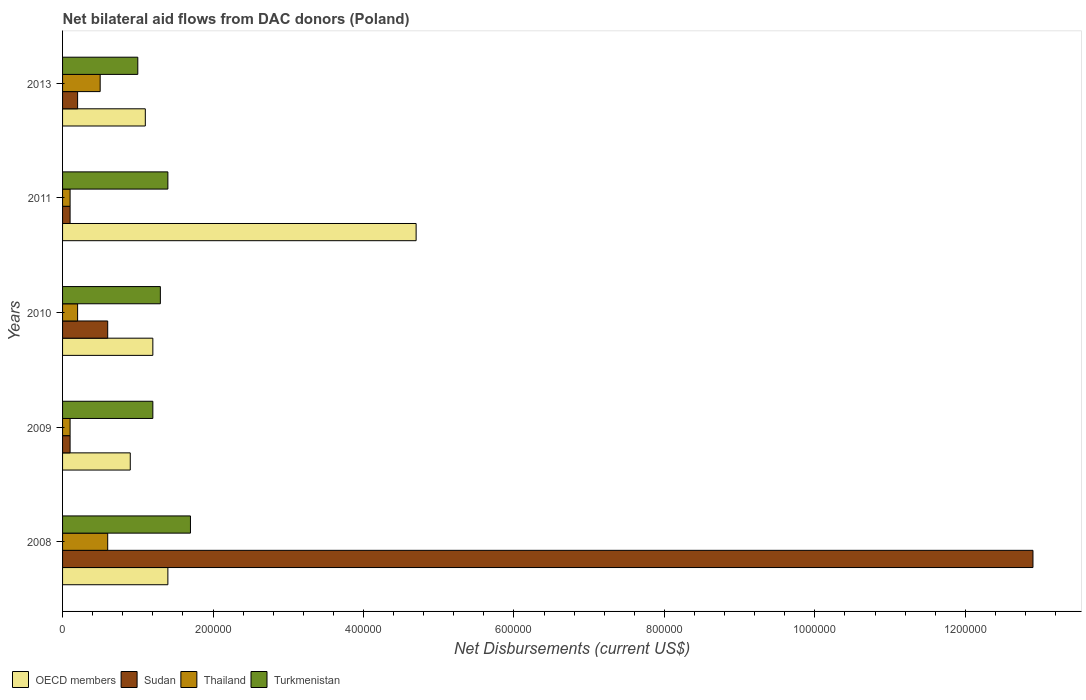How many different coloured bars are there?
Ensure brevity in your answer.  4. Are the number of bars on each tick of the Y-axis equal?
Provide a short and direct response. Yes. How many bars are there on the 4th tick from the bottom?
Provide a succinct answer. 4. In how many cases, is the number of bars for a given year not equal to the number of legend labels?
Provide a short and direct response. 0. Across all years, what is the maximum net bilateral aid flows in Sudan?
Keep it short and to the point. 1.29e+06. Across all years, what is the minimum net bilateral aid flows in Turkmenistan?
Provide a succinct answer. 1.00e+05. What is the total net bilateral aid flows in Sudan in the graph?
Your answer should be compact. 1.39e+06. What is the difference between the net bilateral aid flows in Thailand in 2010 and that in 2013?
Offer a terse response. -3.00e+04. What is the difference between the net bilateral aid flows in Sudan in 2009 and the net bilateral aid flows in OECD members in 2013?
Provide a succinct answer. -1.00e+05. What is the average net bilateral aid flows in Sudan per year?
Offer a terse response. 2.78e+05. In the year 2011, what is the difference between the net bilateral aid flows in OECD members and net bilateral aid flows in Sudan?
Your answer should be very brief. 4.60e+05. What is the ratio of the net bilateral aid flows in Turkmenistan in 2009 to that in 2013?
Offer a very short reply. 1.2. Is the net bilateral aid flows in Turkmenistan in 2009 less than that in 2011?
Keep it short and to the point. Yes. Is the difference between the net bilateral aid flows in OECD members in 2010 and 2013 greater than the difference between the net bilateral aid flows in Sudan in 2010 and 2013?
Your answer should be very brief. No. What is the difference between the highest and the second highest net bilateral aid flows in Turkmenistan?
Provide a succinct answer. 3.00e+04. What is the difference between the highest and the lowest net bilateral aid flows in OECD members?
Provide a short and direct response. 3.80e+05. In how many years, is the net bilateral aid flows in Turkmenistan greater than the average net bilateral aid flows in Turkmenistan taken over all years?
Your response must be concise. 2. Is the sum of the net bilateral aid flows in Sudan in 2010 and 2013 greater than the maximum net bilateral aid flows in Turkmenistan across all years?
Your answer should be very brief. No. Is it the case that in every year, the sum of the net bilateral aid flows in Sudan and net bilateral aid flows in OECD members is greater than the sum of net bilateral aid flows in Turkmenistan and net bilateral aid flows in Thailand?
Make the answer very short. Yes. What does the 1st bar from the top in 2009 represents?
Provide a short and direct response. Turkmenistan. What does the 4th bar from the bottom in 2010 represents?
Your answer should be compact. Turkmenistan. Is it the case that in every year, the sum of the net bilateral aid flows in Turkmenistan and net bilateral aid flows in Sudan is greater than the net bilateral aid flows in OECD members?
Your response must be concise. No. Are all the bars in the graph horizontal?
Provide a short and direct response. Yes. Does the graph contain grids?
Provide a short and direct response. No. How many legend labels are there?
Your answer should be compact. 4. How are the legend labels stacked?
Your answer should be very brief. Horizontal. What is the title of the graph?
Offer a very short reply. Net bilateral aid flows from DAC donors (Poland). What is the label or title of the X-axis?
Offer a terse response. Net Disbursements (current US$). What is the Net Disbursements (current US$) in Sudan in 2008?
Keep it short and to the point. 1.29e+06. What is the Net Disbursements (current US$) of Turkmenistan in 2008?
Provide a short and direct response. 1.70e+05. What is the Net Disbursements (current US$) in Sudan in 2009?
Offer a very short reply. 10000. What is the Net Disbursements (current US$) in Thailand in 2009?
Keep it short and to the point. 10000. What is the Net Disbursements (current US$) of OECD members in 2011?
Your answer should be compact. 4.70e+05. What is the Net Disbursements (current US$) in Thailand in 2011?
Your answer should be compact. 10000. What is the Net Disbursements (current US$) of Turkmenistan in 2011?
Offer a very short reply. 1.40e+05. What is the Net Disbursements (current US$) in OECD members in 2013?
Provide a short and direct response. 1.10e+05. What is the Net Disbursements (current US$) in Sudan in 2013?
Offer a very short reply. 2.00e+04. What is the Net Disbursements (current US$) in Turkmenistan in 2013?
Provide a short and direct response. 1.00e+05. Across all years, what is the maximum Net Disbursements (current US$) of Sudan?
Your response must be concise. 1.29e+06. Across all years, what is the minimum Net Disbursements (current US$) in OECD members?
Give a very brief answer. 9.00e+04. What is the total Net Disbursements (current US$) in OECD members in the graph?
Your answer should be compact. 9.30e+05. What is the total Net Disbursements (current US$) in Sudan in the graph?
Offer a very short reply. 1.39e+06. What is the difference between the Net Disbursements (current US$) in Sudan in 2008 and that in 2009?
Give a very brief answer. 1.28e+06. What is the difference between the Net Disbursements (current US$) in Thailand in 2008 and that in 2009?
Your answer should be very brief. 5.00e+04. What is the difference between the Net Disbursements (current US$) in Turkmenistan in 2008 and that in 2009?
Provide a short and direct response. 5.00e+04. What is the difference between the Net Disbursements (current US$) of OECD members in 2008 and that in 2010?
Your answer should be very brief. 2.00e+04. What is the difference between the Net Disbursements (current US$) in Sudan in 2008 and that in 2010?
Your answer should be very brief. 1.23e+06. What is the difference between the Net Disbursements (current US$) of Turkmenistan in 2008 and that in 2010?
Your answer should be compact. 4.00e+04. What is the difference between the Net Disbursements (current US$) in OECD members in 2008 and that in 2011?
Offer a terse response. -3.30e+05. What is the difference between the Net Disbursements (current US$) in Sudan in 2008 and that in 2011?
Your answer should be very brief. 1.28e+06. What is the difference between the Net Disbursements (current US$) of OECD members in 2008 and that in 2013?
Your response must be concise. 3.00e+04. What is the difference between the Net Disbursements (current US$) in Sudan in 2008 and that in 2013?
Provide a succinct answer. 1.27e+06. What is the difference between the Net Disbursements (current US$) of Thailand in 2008 and that in 2013?
Keep it short and to the point. 10000. What is the difference between the Net Disbursements (current US$) in OECD members in 2009 and that in 2010?
Make the answer very short. -3.00e+04. What is the difference between the Net Disbursements (current US$) in OECD members in 2009 and that in 2011?
Provide a succinct answer. -3.80e+05. What is the difference between the Net Disbursements (current US$) in Sudan in 2009 and that in 2011?
Your answer should be compact. 0. What is the difference between the Net Disbursements (current US$) in Turkmenistan in 2009 and that in 2011?
Offer a very short reply. -2.00e+04. What is the difference between the Net Disbursements (current US$) of OECD members in 2009 and that in 2013?
Your response must be concise. -2.00e+04. What is the difference between the Net Disbursements (current US$) of Thailand in 2009 and that in 2013?
Provide a short and direct response. -4.00e+04. What is the difference between the Net Disbursements (current US$) of OECD members in 2010 and that in 2011?
Ensure brevity in your answer.  -3.50e+05. What is the difference between the Net Disbursements (current US$) of Thailand in 2010 and that in 2011?
Provide a succinct answer. 10000. What is the difference between the Net Disbursements (current US$) in Turkmenistan in 2010 and that in 2011?
Provide a short and direct response. -10000. What is the difference between the Net Disbursements (current US$) of Sudan in 2010 and that in 2013?
Your answer should be very brief. 4.00e+04. What is the difference between the Net Disbursements (current US$) of Thailand in 2010 and that in 2013?
Make the answer very short. -3.00e+04. What is the difference between the Net Disbursements (current US$) in Turkmenistan in 2011 and that in 2013?
Give a very brief answer. 4.00e+04. What is the difference between the Net Disbursements (current US$) of Sudan in 2008 and the Net Disbursements (current US$) of Thailand in 2009?
Offer a very short reply. 1.28e+06. What is the difference between the Net Disbursements (current US$) of Sudan in 2008 and the Net Disbursements (current US$) of Turkmenistan in 2009?
Make the answer very short. 1.17e+06. What is the difference between the Net Disbursements (current US$) in OECD members in 2008 and the Net Disbursements (current US$) in Sudan in 2010?
Provide a succinct answer. 8.00e+04. What is the difference between the Net Disbursements (current US$) in OECD members in 2008 and the Net Disbursements (current US$) in Thailand in 2010?
Ensure brevity in your answer.  1.20e+05. What is the difference between the Net Disbursements (current US$) in Sudan in 2008 and the Net Disbursements (current US$) in Thailand in 2010?
Provide a short and direct response. 1.27e+06. What is the difference between the Net Disbursements (current US$) in Sudan in 2008 and the Net Disbursements (current US$) in Turkmenistan in 2010?
Offer a very short reply. 1.16e+06. What is the difference between the Net Disbursements (current US$) of Thailand in 2008 and the Net Disbursements (current US$) of Turkmenistan in 2010?
Offer a very short reply. -7.00e+04. What is the difference between the Net Disbursements (current US$) of OECD members in 2008 and the Net Disbursements (current US$) of Sudan in 2011?
Your answer should be compact. 1.30e+05. What is the difference between the Net Disbursements (current US$) in OECD members in 2008 and the Net Disbursements (current US$) in Turkmenistan in 2011?
Your answer should be compact. 0. What is the difference between the Net Disbursements (current US$) of Sudan in 2008 and the Net Disbursements (current US$) of Thailand in 2011?
Your answer should be compact. 1.28e+06. What is the difference between the Net Disbursements (current US$) of Sudan in 2008 and the Net Disbursements (current US$) of Turkmenistan in 2011?
Your answer should be compact. 1.15e+06. What is the difference between the Net Disbursements (current US$) in OECD members in 2008 and the Net Disbursements (current US$) in Turkmenistan in 2013?
Provide a short and direct response. 4.00e+04. What is the difference between the Net Disbursements (current US$) of Sudan in 2008 and the Net Disbursements (current US$) of Thailand in 2013?
Give a very brief answer. 1.24e+06. What is the difference between the Net Disbursements (current US$) in Sudan in 2008 and the Net Disbursements (current US$) in Turkmenistan in 2013?
Give a very brief answer. 1.19e+06. What is the difference between the Net Disbursements (current US$) of Sudan in 2009 and the Net Disbursements (current US$) of Thailand in 2010?
Ensure brevity in your answer.  -10000. What is the difference between the Net Disbursements (current US$) of Sudan in 2009 and the Net Disbursements (current US$) of Turkmenistan in 2010?
Keep it short and to the point. -1.20e+05. What is the difference between the Net Disbursements (current US$) of Thailand in 2009 and the Net Disbursements (current US$) of Turkmenistan in 2010?
Ensure brevity in your answer.  -1.20e+05. What is the difference between the Net Disbursements (current US$) of OECD members in 2009 and the Net Disbursements (current US$) of Sudan in 2011?
Your answer should be very brief. 8.00e+04. What is the difference between the Net Disbursements (current US$) of Sudan in 2009 and the Net Disbursements (current US$) of Thailand in 2011?
Keep it short and to the point. 0. What is the difference between the Net Disbursements (current US$) in OECD members in 2009 and the Net Disbursements (current US$) in Sudan in 2013?
Your response must be concise. 7.00e+04. What is the difference between the Net Disbursements (current US$) of OECD members in 2009 and the Net Disbursements (current US$) of Turkmenistan in 2013?
Ensure brevity in your answer.  -10000. What is the difference between the Net Disbursements (current US$) in OECD members in 2010 and the Net Disbursements (current US$) in Sudan in 2011?
Give a very brief answer. 1.10e+05. What is the difference between the Net Disbursements (current US$) of OECD members in 2010 and the Net Disbursements (current US$) of Turkmenistan in 2011?
Ensure brevity in your answer.  -2.00e+04. What is the difference between the Net Disbursements (current US$) of Sudan in 2010 and the Net Disbursements (current US$) of Turkmenistan in 2011?
Ensure brevity in your answer.  -8.00e+04. What is the difference between the Net Disbursements (current US$) of Thailand in 2010 and the Net Disbursements (current US$) of Turkmenistan in 2011?
Make the answer very short. -1.20e+05. What is the difference between the Net Disbursements (current US$) of Sudan in 2010 and the Net Disbursements (current US$) of Thailand in 2013?
Your answer should be very brief. 10000. What is the difference between the Net Disbursements (current US$) of Sudan in 2010 and the Net Disbursements (current US$) of Turkmenistan in 2013?
Give a very brief answer. -4.00e+04. What is the difference between the Net Disbursements (current US$) in OECD members in 2011 and the Net Disbursements (current US$) in Sudan in 2013?
Make the answer very short. 4.50e+05. What is the difference between the Net Disbursements (current US$) in OECD members in 2011 and the Net Disbursements (current US$) in Thailand in 2013?
Your answer should be very brief. 4.20e+05. What is the difference between the Net Disbursements (current US$) in OECD members in 2011 and the Net Disbursements (current US$) in Turkmenistan in 2013?
Your answer should be very brief. 3.70e+05. What is the average Net Disbursements (current US$) in OECD members per year?
Make the answer very short. 1.86e+05. What is the average Net Disbursements (current US$) of Sudan per year?
Your answer should be compact. 2.78e+05. What is the average Net Disbursements (current US$) of Turkmenistan per year?
Offer a very short reply. 1.32e+05. In the year 2008, what is the difference between the Net Disbursements (current US$) of OECD members and Net Disbursements (current US$) of Sudan?
Provide a short and direct response. -1.15e+06. In the year 2008, what is the difference between the Net Disbursements (current US$) in OECD members and Net Disbursements (current US$) in Thailand?
Keep it short and to the point. 8.00e+04. In the year 2008, what is the difference between the Net Disbursements (current US$) of Sudan and Net Disbursements (current US$) of Thailand?
Make the answer very short. 1.23e+06. In the year 2008, what is the difference between the Net Disbursements (current US$) of Sudan and Net Disbursements (current US$) of Turkmenistan?
Ensure brevity in your answer.  1.12e+06. In the year 2008, what is the difference between the Net Disbursements (current US$) in Thailand and Net Disbursements (current US$) in Turkmenistan?
Provide a short and direct response. -1.10e+05. In the year 2009, what is the difference between the Net Disbursements (current US$) of OECD members and Net Disbursements (current US$) of Turkmenistan?
Offer a very short reply. -3.00e+04. In the year 2009, what is the difference between the Net Disbursements (current US$) of Sudan and Net Disbursements (current US$) of Thailand?
Your answer should be compact. 0. In the year 2009, what is the difference between the Net Disbursements (current US$) in Thailand and Net Disbursements (current US$) in Turkmenistan?
Provide a short and direct response. -1.10e+05. In the year 2010, what is the difference between the Net Disbursements (current US$) in OECD members and Net Disbursements (current US$) in Turkmenistan?
Your answer should be very brief. -10000. In the year 2010, what is the difference between the Net Disbursements (current US$) of Sudan and Net Disbursements (current US$) of Thailand?
Offer a terse response. 4.00e+04. In the year 2010, what is the difference between the Net Disbursements (current US$) in Sudan and Net Disbursements (current US$) in Turkmenistan?
Provide a short and direct response. -7.00e+04. In the year 2010, what is the difference between the Net Disbursements (current US$) of Thailand and Net Disbursements (current US$) of Turkmenistan?
Offer a very short reply. -1.10e+05. In the year 2011, what is the difference between the Net Disbursements (current US$) in OECD members and Net Disbursements (current US$) in Thailand?
Provide a succinct answer. 4.60e+05. In the year 2011, what is the difference between the Net Disbursements (current US$) in Sudan and Net Disbursements (current US$) in Thailand?
Provide a short and direct response. 0. In the year 2011, what is the difference between the Net Disbursements (current US$) in Sudan and Net Disbursements (current US$) in Turkmenistan?
Give a very brief answer. -1.30e+05. In the year 2011, what is the difference between the Net Disbursements (current US$) of Thailand and Net Disbursements (current US$) of Turkmenistan?
Ensure brevity in your answer.  -1.30e+05. In the year 2013, what is the difference between the Net Disbursements (current US$) in OECD members and Net Disbursements (current US$) in Sudan?
Offer a very short reply. 9.00e+04. In the year 2013, what is the difference between the Net Disbursements (current US$) of OECD members and Net Disbursements (current US$) of Turkmenistan?
Offer a terse response. 10000. In the year 2013, what is the difference between the Net Disbursements (current US$) of Sudan and Net Disbursements (current US$) of Turkmenistan?
Provide a short and direct response. -8.00e+04. In the year 2013, what is the difference between the Net Disbursements (current US$) of Thailand and Net Disbursements (current US$) of Turkmenistan?
Offer a very short reply. -5.00e+04. What is the ratio of the Net Disbursements (current US$) in OECD members in 2008 to that in 2009?
Your answer should be very brief. 1.56. What is the ratio of the Net Disbursements (current US$) in Sudan in 2008 to that in 2009?
Your answer should be very brief. 129. What is the ratio of the Net Disbursements (current US$) in Turkmenistan in 2008 to that in 2009?
Give a very brief answer. 1.42. What is the ratio of the Net Disbursements (current US$) in OECD members in 2008 to that in 2010?
Your answer should be very brief. 1.17. What is the ratio of the Net Disbursements (current US$) in Sudan in 2008 to that in 2010?
Your answer should be compact. 21.5. What is the ratio of the Net Disbursements (current US$) in Thailand in 2008 to that in 2010?
Offer a very short reply. 3. What is the ratio of the Net Disbursements (current US$) in Turkmenistan in 2008 to that in 2010?
Your answer should be very brief. 1.31. What is the ratio of the Net Disbursements (current US$) in OECD members in 2008 to that in 2011?
Provide a short and direct response. 0.3. What is the ratio of the Net Disbursements (current US$) of Sudan in 2008 to that in 2011?
Offer a terse response. 129. What is the ratio of the Net Disbursements (current US$) of Thailand in 2008 to that in 2011?
Make the answer very short. 6. What is the ratio of the Net Disbursements (current US$) in Turkmenistan in 2008 to that in 2011?
Make the answer very short. 1.21. What is the ratio of the Net Disbursements (current US$) of OECD members in 2008 to that in 2013?
Your response must be concise. 1.27. What is the ratio of the Net Disbursements (current US$) in Sudan in 2008 to that in 2013?
Ensure brevity in your answer.  64.5. What is the ratio of the Net Disbursements (current US$) of Thailand in 2008 to that in 2013?
Ensure brevity in your answer.  1.2. What is the ratio of the Net Disbursements (current US$) of Thailand in 2009 to that in 2010?
Provide a succinct answer. 0.5. What is the ratio of the Net Disbursements (current US$) in Turkmenistan in 2009 to that in 2010?
Provide a short and direct response. 0.92. What is the ratio of the Net Disbursements (current US$) of OECD members in 2009 to that in 2011?
Provide a succinct answer. 0.19. What is the ratio of the Net Disbursements (current US$) of Thailand in 2009 to that in 2011?
Offer a very short reply. 1. What is the ratio of the Net Disbursements (current US$) in OECD members in 2009 to that in 2013?
Offer a very short reply. 0.82. What is the ratio of the Net Disbursements (current US$) of Sudan in 2009 to that in 2013?
Your response must be concise. 0.5. What is the ratio of the Net Disbursements (current US$) of Turkmenistan in 2009 to that in 2013?
Make the answer very short. 1.2. What is the ratio of the Net Disbursements (current US$) of OECD members in 2010 to that in 2011?
Offer a terse response. 0.26. What is the ratio of the Net Disbursements (current US$) of Sudan in 2010 to that in 2011?
Your answer should be compact. 6. What is the ratio of the Net Disbursements (current US$) in OECD members in 2010 to that in 2013?
Provide a succinct answer. 1.09. What is the ratio of the Net Disbursements (current US$) of OECD members in 2011 to that in 2013?
Offer a terse response. 4.27. What is the ratio of the Net Disbursements (current US$) in Sudan in 2011 to that in 2013?
Your answer should be very brief. 0.5. What is the ratio of the Net Disbursements (current US$) in Thailand in 2011 to that in 2013?
Your response must be concise. 0.2. What is the difference between the highest and the second highest Net Disbursements (current US$) of OECD members?
Ensure brevity in your answer.  3.30e+05. What is the difference between the highest and the second highest Net Disbursements (current US$) of Sudan?
Provide a short and direct response. 1.23e+06. What is the difference between the highest and the lowest Net Disbursements (current US$) of OECD members?
Your answer should be compact. 3.80e+05. What is the difference between the highest and the lowest Net Disbursements (current US$) in Sudan?
Offer a very short reply. 1.28e+06. What is the difference between the highest and the lowest Net Disbursements (current US$) of Thailand?
Make the answer very short. 5.00e+04. 